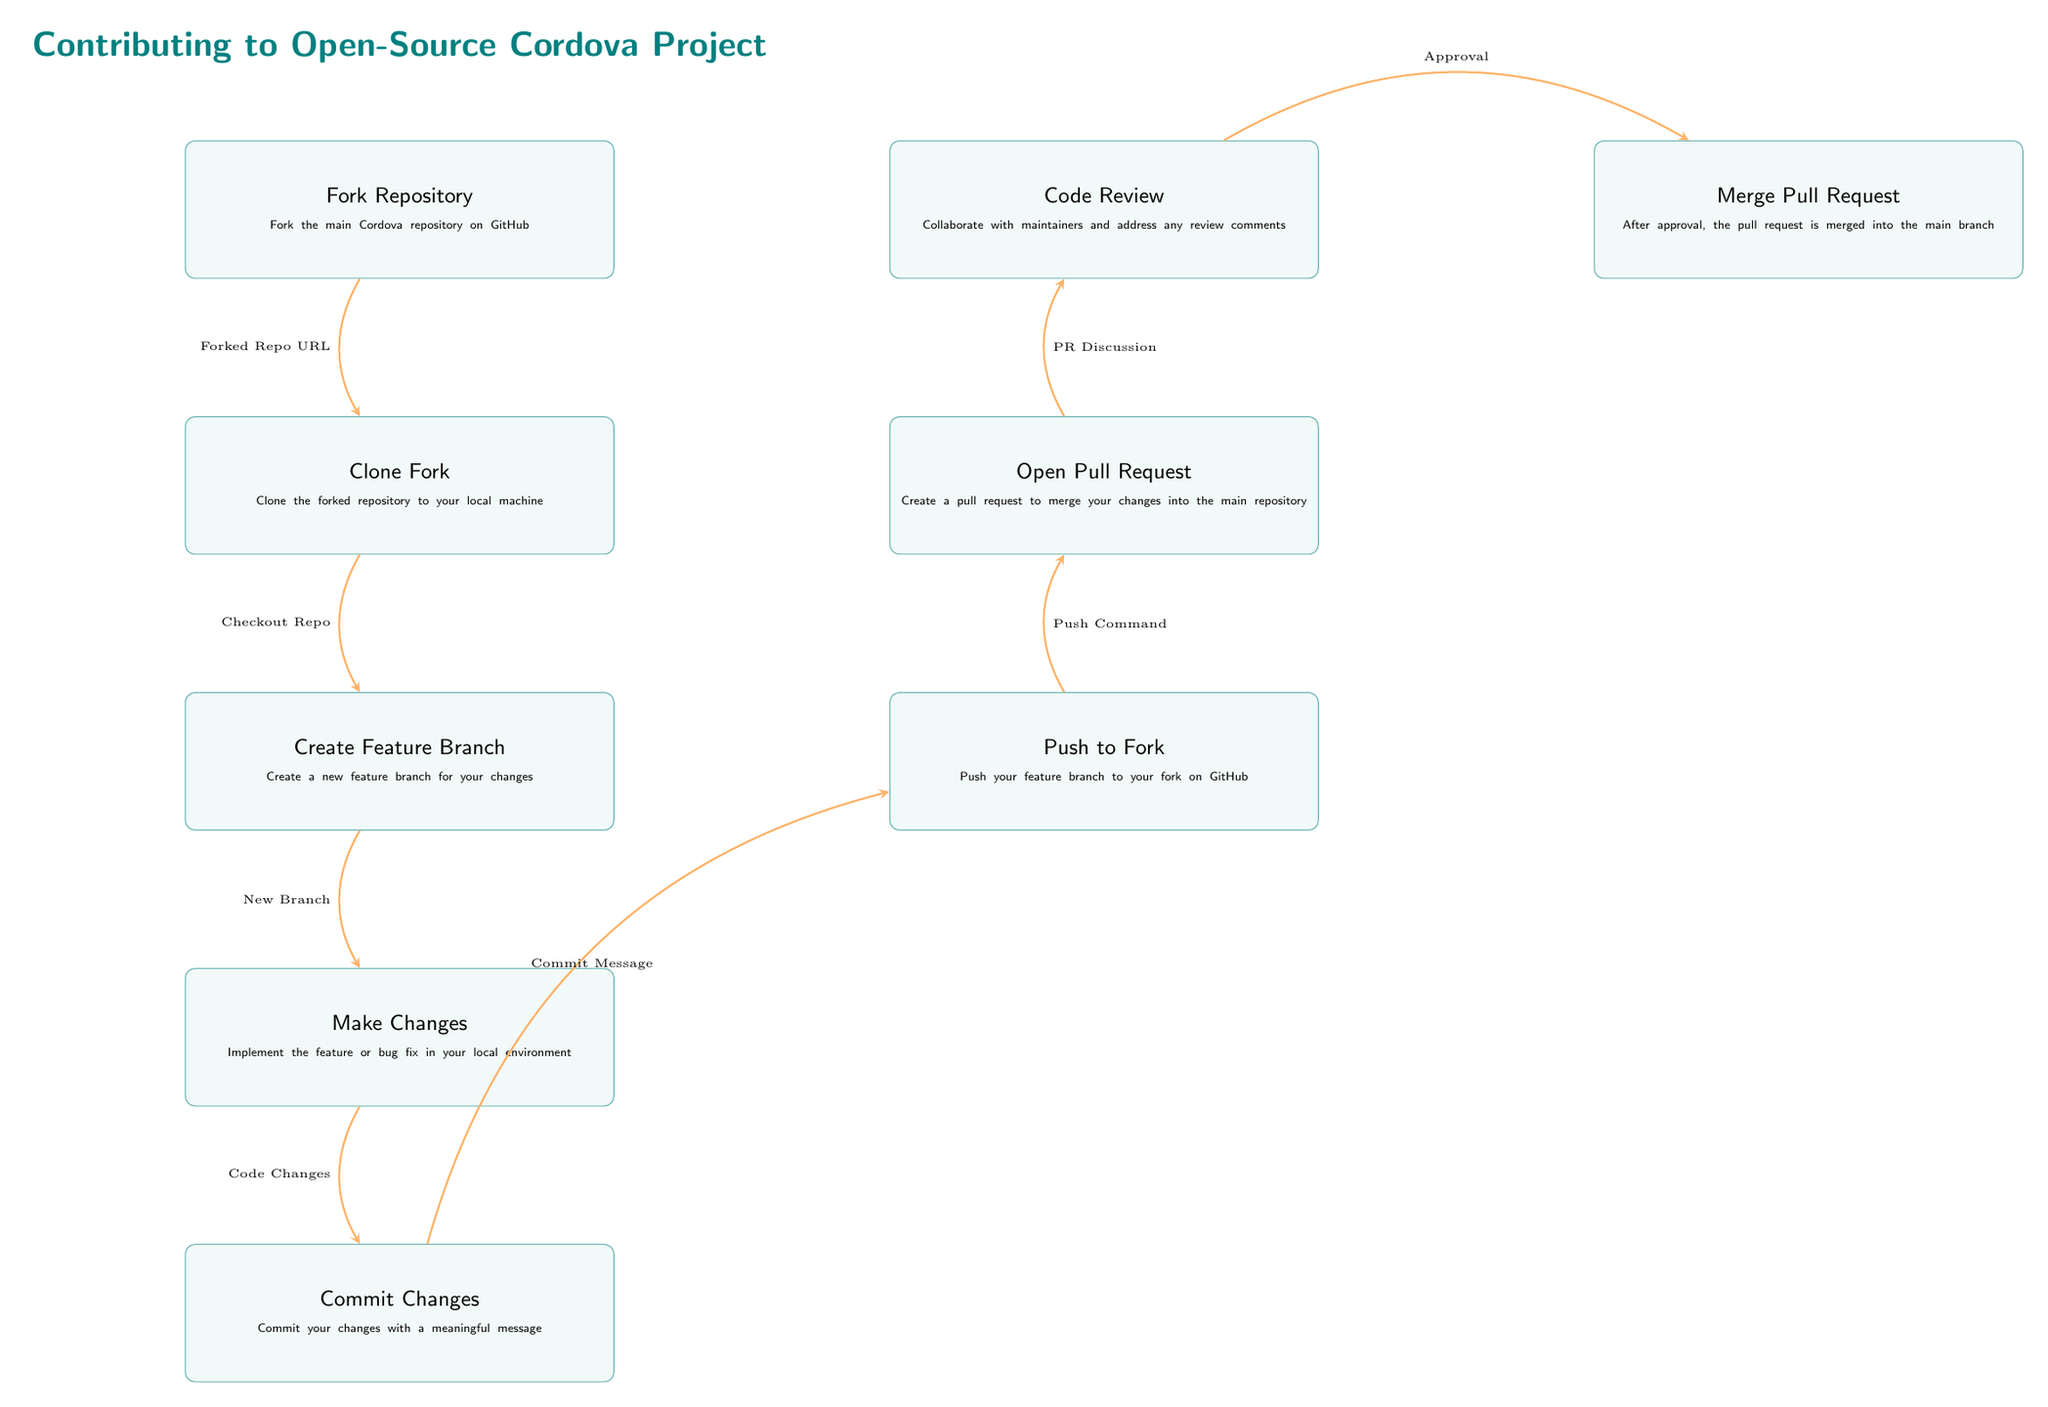What is the first step in the diagram? The first step in the diagram is represented by the first node, which is labeled as "Fork Repository." This indicates that the initial action to be taken when contributing to an open-source Cordova project is to fork the main repository.
Answer: Fork Repository How many main steps are outlined in the diagram? By counting the distinct boxes in the diagram that represent steps in the contribution process, we see there are a total of 9 main steps outlined. Each node corresponds to a specific action to be taken.
Answer: 9 What is the relationship between "Clone Fork" and "Create Feature Branch"? The "Clone Fork" node is positioned directly below the "Fork Repository" node, indicating that it is the next action to be completed. The "Create Feature Branch" node comes after "Clone Fork," showing that after cloning the repository, the next step is to create a feature branch.
Answer: Sequential What does the arrow between "Open Pull Request" and "Code Review" indicate? The arrow indicates a flow of process, showing that after the "Open Pull Request" step is completed, the next step is "Code Review." This demonstrates that reviewing the code is dependent on the submission of a pull request.
Answer: Dependency Which step involves communication with maintainers? The step labeled "Code Review" involves collaboration and communication with maintainers, as contributors need to address any review comments that arise during this process.
Answer: Code Review What is the last step in the flow of the diagram? The last step in the diagram is represented by the node labeled "Merge Pull Request." This signifies the final action after all previous steps, particularly after the approval of code changes.
Answer: Merge Pull Request How does "Push to Fork" relate to "Commit Changes"? The "Push to Fork" step follows "Commit Changes" in the process flow. This means the changes that have been committed are then pushed to the contributor's forked repository on GitHub, demonstrating a direct progression from committing code to sharing it on the platform.
Answer: Progression Which node mentions a meaningful message? The node labeled "Commit Changes" specifically states that changes should be committed with a meaningful message, indicating the importance of documenting your changes clearly.
Answer: Commit Changes What is suggested before merging a pull request? Before merging a pull request, the diagram suggests that the changes undergo a "Code Review," where maintainers evaluate the submitted changes and provide feedback. Merging occurs after this review process.
Answer: Code Review 